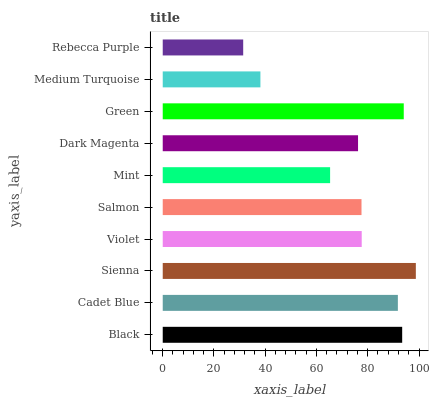Is Rebecca Purple the minimum?
Answer yes or no. Yes. Is Sienna the maximum?
Answer yes or no. Yes. Is Cadet Blue the minimum?
Answer yes or no. No. Is Cadet Blue the maximum?
Answer yes or no. No. Is Black greater than Cadet Blue?
Answer yes or no. Yes. Is Cadet Blue less than Black?
Answer yes or no. Yes. Is Cadet Blue greater than Black?
Answer yes or no. No. Is Black less than Cadet Blue?
Answer yes or no. No. Is Violet the high median?
Answer yes or no. Yes. Is Salmon the low median?
Answer yes or no. Yes. Is Mint the high median?
Answer yes or no. No. Is Black the low median?
Answer yes or no. No. 